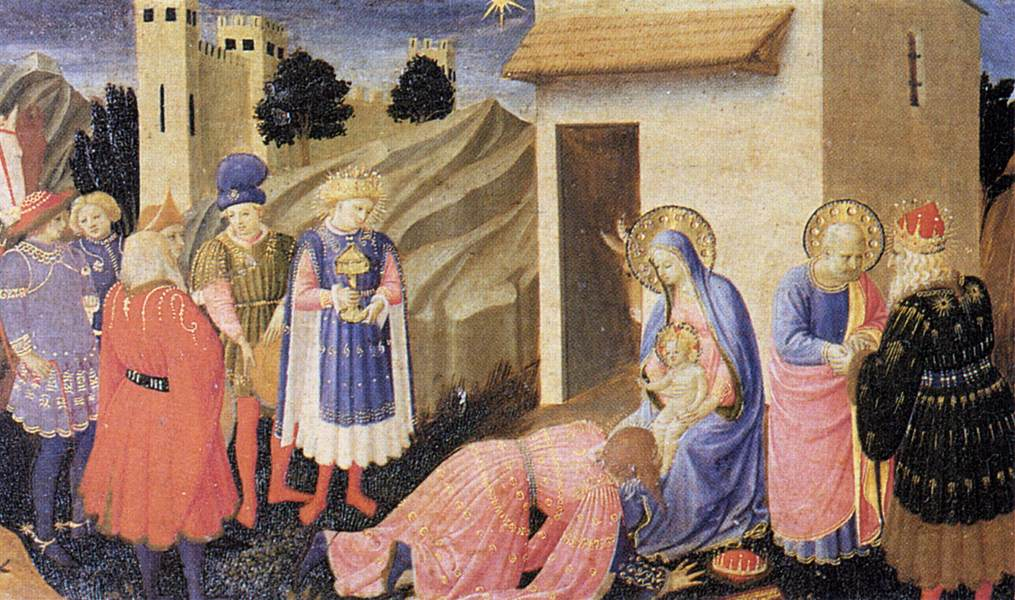What might the castle and the church in the background symbolize? The castle and the church in the background are significant elements in this Gothic artwork. The castle could symbolize the temporal power and the protection offered by the worldly rulers who are symbolized by the Magi, while the church represents spiritual salvation and divine presence. Together, they highlight the unity of earthly and heavenly realms in the context of the Adoration of the Magi. The inclusion of these structures adds depth to the painting, pulling the viewer’s attention to the divine infant Jesus in the foreground while underscoring the broader religious and social hierarchies of the era. Could you elaborate more on the significance of the star above the scene? The star shining brightly above the scene is the Star of Bethlehem, a crucial element in the narrative of the Adoration of the Magi. It is said to have guided the Wise Men to the birthplace of Jesus. In the context of this painting, the star serves multiple symbolic purposes: it acts as a divine beacon, illuminating the holy figures below and emphasizing the miraculous nature of the event. Additionally, it symbolizes enlightenment, divine guidance, and the fulfillment of prophecy. The artist's placement of the star above the Virgin Mary and Jesus ensures it draws the viewer’s eye, linking the celestial sign to the sacred moment happening below. 